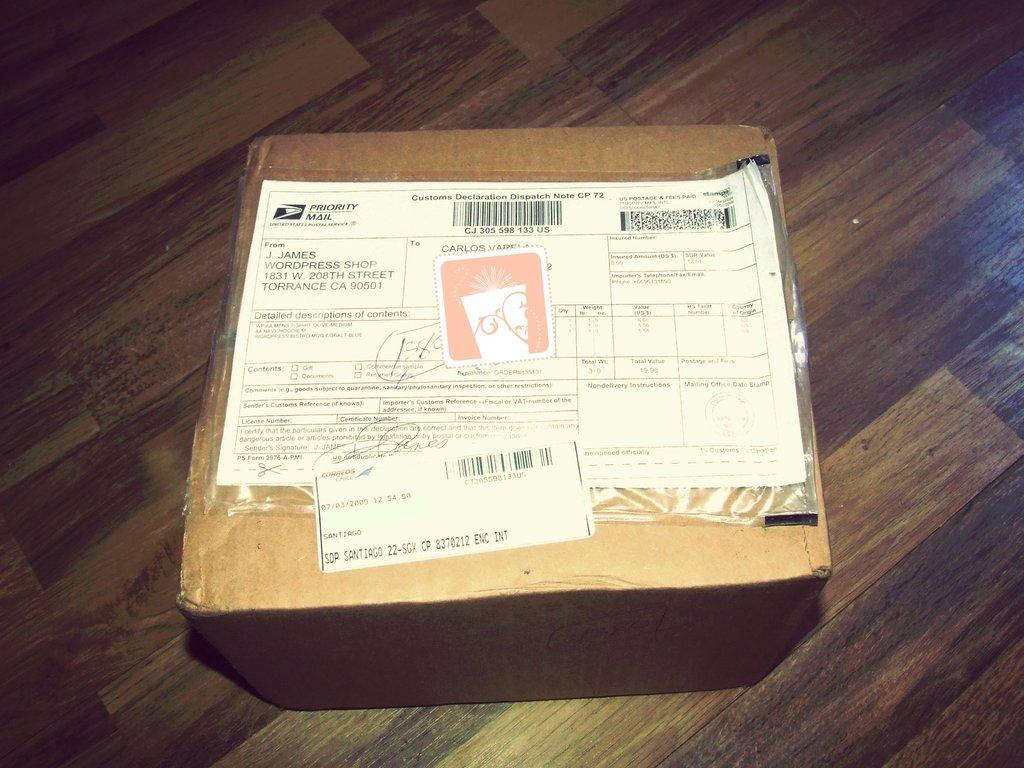<image>
Describe the image concisely. Brown box with the United States Postal Service Priority Mail slip on top. 